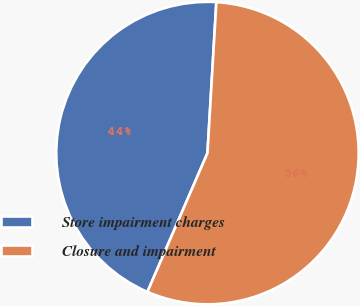Convert chart. <chart><loc_0><loc_0><loc_500><loc_500><pie_chart><fcel>Store impairment charges<fcel>Closure and impairment<nl><fcel>44.44%<fcel>55.56%<nl></chart> 